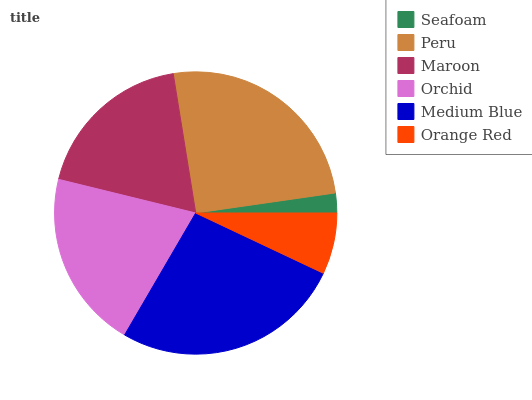Is Seafoam the minimum?
Answer yes or no. Yes. Is Medium Blue the maximum?
Answer yes or no. Yes. Is Peru the minimum?
Answer yes or no. No. Is Peru the maximum?
Answer yes or no. No. Is Peru greater than Seafoam?
Answer yes or no. Yes. Is Seafoam less than Peru?
Answer yes or no. Yes. Is Seafoam greater than Peru?
Answer yes or no. No. Is Peru less than Seafoam?
Answer yes or no. No. Is Orchid the high median?
Answer yes or no. Yes. Is Maroon the low median?
Answer yes or no. Yes. Is Seafoam the high median?
Answer yes or no. No. Is Medium Blue the low median?
Answer yes or no. No. 